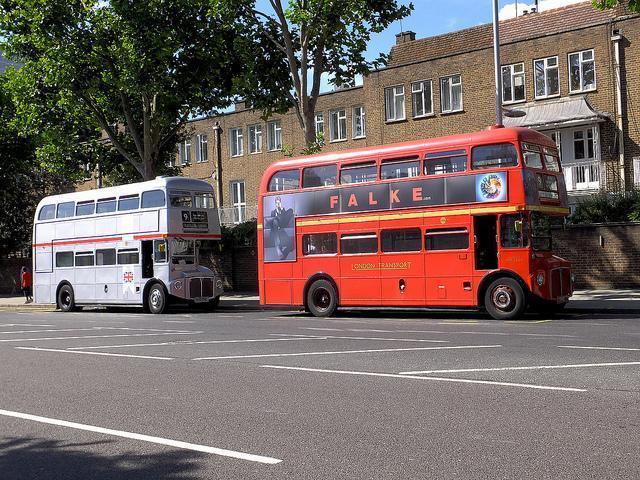How many buses are there?
Give a very brief answer. 2. How many buses are in the photo?
Give a very brief answer. 2. 